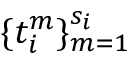<formula> <loc_0><loc_0><loc_500><loc_500>\{ t _ { i } ^ { m } \} _ { m = 1 } ^ { s _ { i } }</formula> 